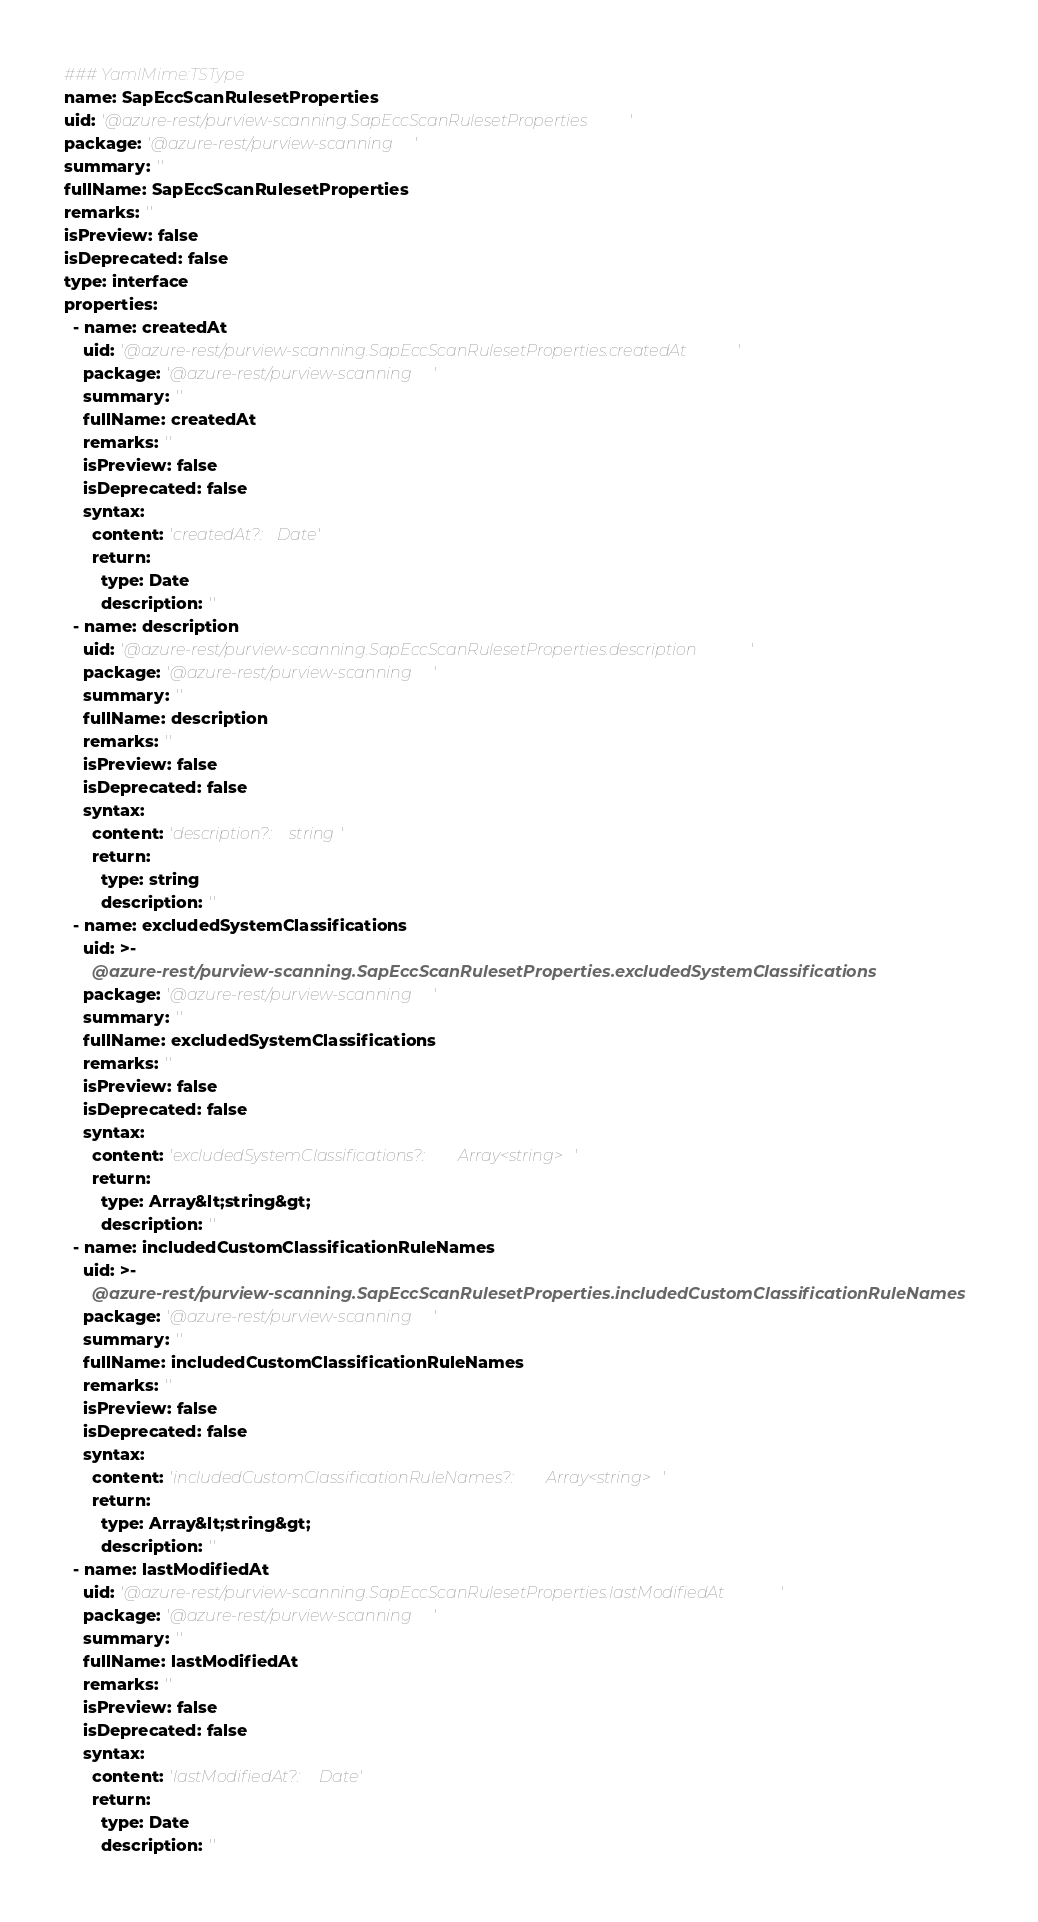Convert code to text. <code><loc_0><loc_0><loc_500><loc_500><_YAML_>### YamlMime:TSType
name: SapEccScanRulesetProperties
uid: '@azure-rest/purview-scanning.SapEccScanRulesetProperties'
package: '@azure-rest/purview-scanning'
summary: ''
fullName: SapEccScanRulesetProperties
remarks: ''
isPreview: false
isDeprecated: false
type: interface
properties:
  - name: createdAt
    uid: '@azure-rest/purview-scanning.SapEccScanRulesetProperties.createdAt'
    package: '@azure-rest/purview-scanning'
    summary: ''
    fullName: createdAt
    remarks: ''
    isPreview: false
    isDeprecated: false
    syntax:
      content: 'createdAt?: Date'
      return:
        type: Date
        description: ''
  - name: description
    uid: '@azure-rest/purview-scanning.SapEccScanRulesetProperties.description'
    package: '@azure-rest/purview-scanning'
    summary: ''
    fullName: description
    remarks: ''
    isPreview: false
    isDeprecated: false
    syntax:
      content: 'description?: string'
      return:
        type: string
        description: ''
  - name: excludedSystemClassifications
    uid: >-
      @azure-rest/purview-scanning.SapEccScanRulesetProperties.excludedSystemClassifications
    package: '@azure-rest/purview-scanning'
    summary: ''
    fullName: excludedSystemClassifications
    remarks: ''
    isPreview: false
    isDeprecated: false
    syntax:
      content: 'excludedSystemClassifications?: Array<string>'
      return:
        type: Array&lt;string&gt;
        description: ''
  - name: includedCustomClassificationRuleNames
    uid: >-
      @azure-rest/purview-scanning.SapEccScanRulesetProperties.includedCustomClassificationRuleNames
    package: '@azure-rest/purview-scanning'
    summary: ''
    fullName: includedCustomClassificationRuleNames
    remarks: ''
    isPreview: false
    isDeprecated: false
    syntax:
      content: 'includedCustomClassificationRuleNames?: Array<string>'
      return:
        type: Array&lt;string&gt;
        description: ''
  - name: lastModifiedAt
    uid: '@azure-rest/purview-scanning.SapEccScanRulesetProperties.lastModifiedAt'
    package: '@azure-rest/purview-scanning'
    summary: ''
    fullName: lastModifiedAt
    remarks: ''
    isPreview: false
    isDeprecated: false
    syntax:
      content: 'lastModifiedAt?: Date'
      return:
        type: Date
        description: ''</code> 